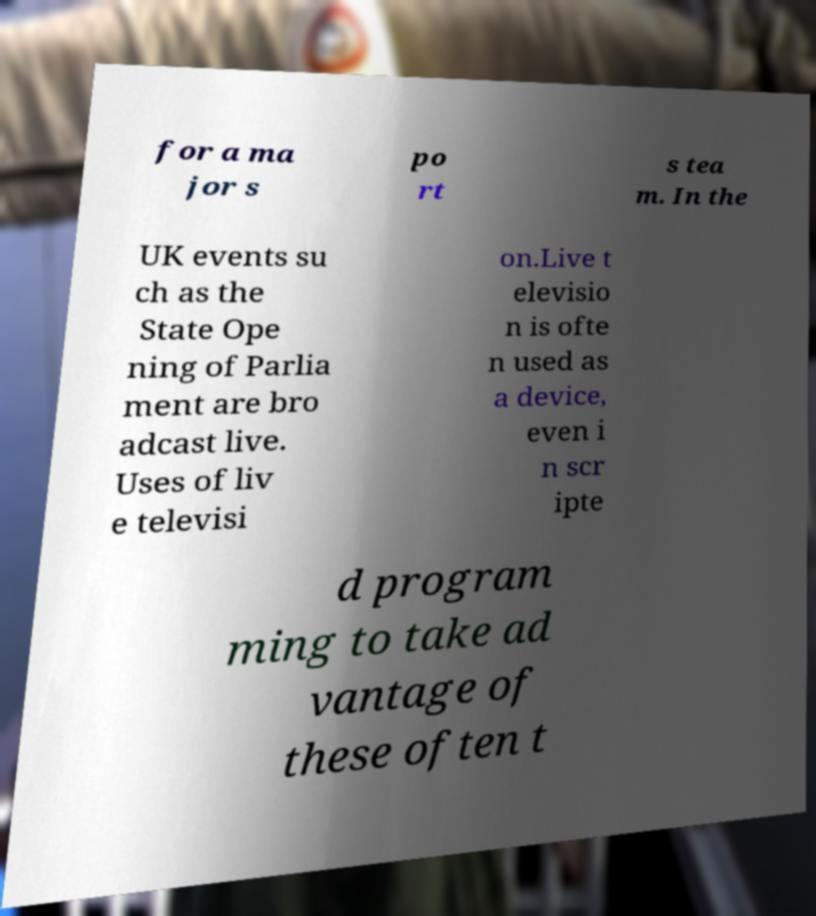For documentation purposes, I need the text within this image transcribed. Could you provide that? for a ma jor s po rt s tea m. In the UK events su ch as the State Ope ning of Parlia ment are bro adcast live. Uses of liv e televisi on.Live t elevisio n is ofte n used as a device, even i n scr ipte d program ming to take ad vantage of these often t 